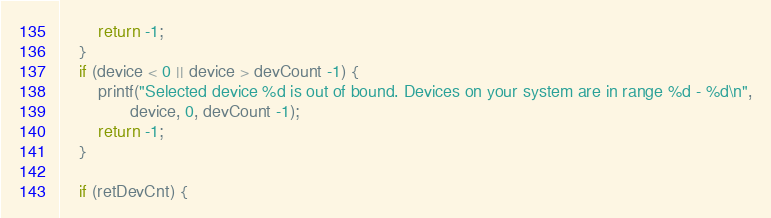<code> <loc_0><loc_0><loc_500><loc_500><_C++_>        return -1;
    }
    if (device < 0 || device > devCount -1) {
        printf("Selected device %d is out of bound. Devices on your system are in range %d - %d\n",
               device, 0, devCount -1);
        return -1;
    }

    if (retDevCnt) {</code> 